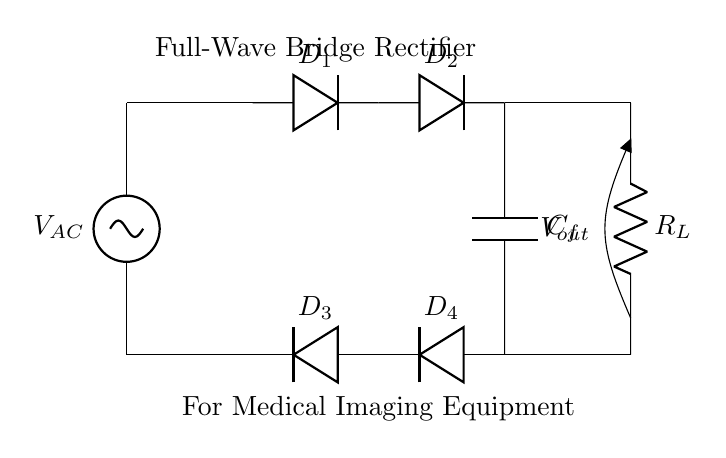What is the purpose of the capacitor in this circuit? The capacitor, labeled as C_f, is used for filtering in a full-wave bridge rectifier. Its primary purpose is to smooth out the rectified output by reducing the ripple voltage, providing a more constant voltage level suitable for powering medical imaging equipment.
Answer: Filtering What type of rectifier is shown in this diagram? The diagram displays a full-wave bridge rectifier, which uses four diodes arranged in a bridge configuration to convert alternating current to direct current efficiently. This type ensures that both halves of the AC waveform contribute to the output.
Answer: Full-wave bridge How many diodes are in the bridge rectifier? The circuit incorporates four diodes, specifically labeled as D1, D2, D3, and D4, arranged to enable full-wave rectification of the input AC voltage.
Answer: Four What is the load connected to the output? The load connected to the output is a resistor, labeled R_L, which represents the medical imaging equipment or any device requiring the rectified power from the circuit.
Answer: Resistor What is the input voltage type for this circuit? The input voltage type is alternating current, labeled V_AC on the circuit diagram, which is necessary for the bridge rectifier to function properly, as it converts AC to DC.
Answer: Alternating current What happens to the output if one diode fails? If one diode in the bridge rectifier fails, the output voltage will be lower, and the rectification process will be compromised, potentially resulting in non-uniform DC output. This could negatively impact the performance of the medical imaging equipment powered by this circuit.
Answer: Output drops What does the label V_out represent in this circuit? The label V_out indicates the output voltage after rectification, which is the DC voltage supplied to the load R_L, crucial for operating medical imaging equipment efficiently.
Answer: Output voltage 